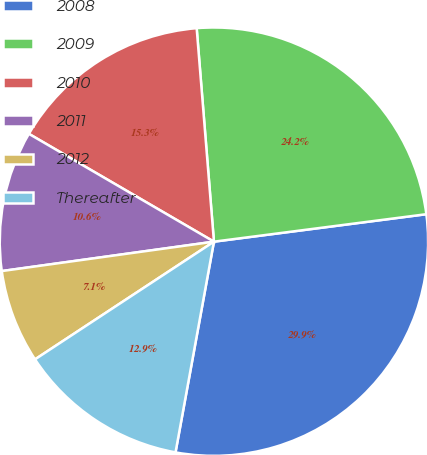Convert chart. <chart><loc_0><loc_0><loc_500><loc_500><pie_chart><fcel>2008<fcel>2009<fcel>2010<fcel>2011<fcel>2012<fcel>Thereafter<nl><fcel>29.92%<fcel>24.24%<fcel>15.32%<fcel>10.59%<fcel>7.07%<fcel>12.87%<nl></chart> 